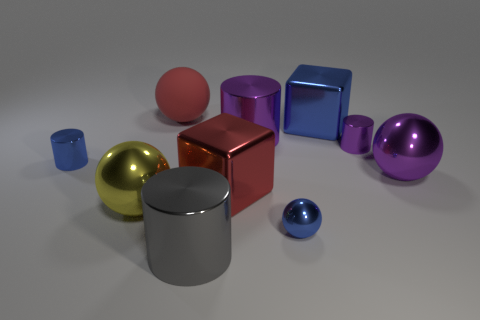Subtract 1 balls. How many balls are left? 3 Subtract all cylinders. How many objects are left? 6 Add 7 large purple metal cylinders. How many large purple metal cylinders exist? 8 Subtract 1 blue cubes. How many objects are left? 9 Subtract all big red metal objects. Subtract all tiny cyan shiny balls. How many objects are left? 9 Add 6 metallic cylinders. How many metallic cylinders are left? 10 